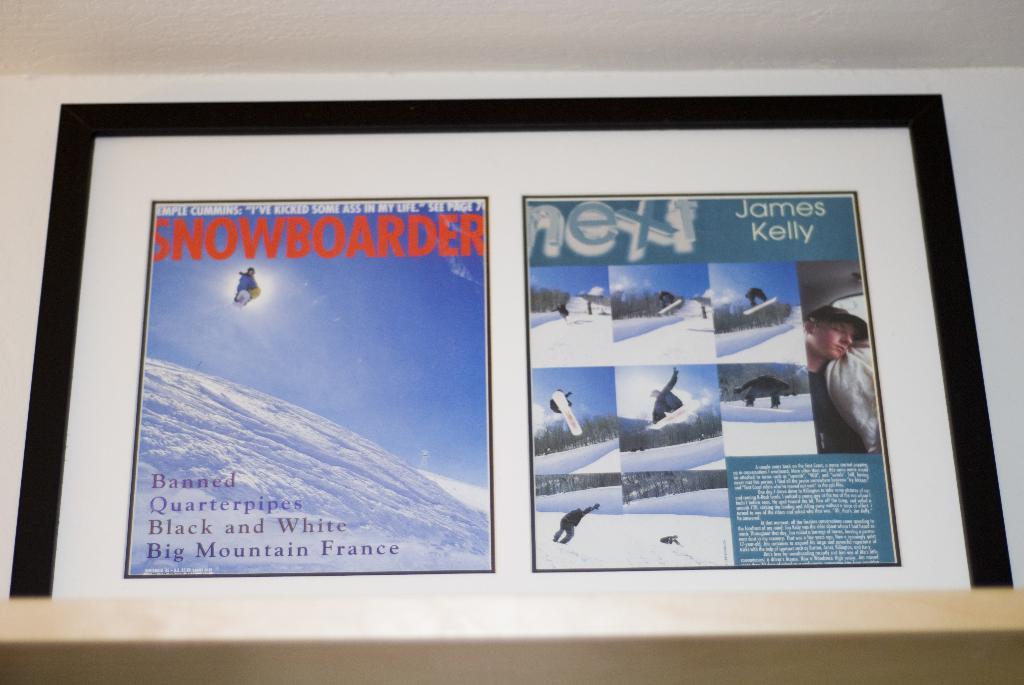Where is this mountain located?
Provide a short and direct response. France. What name is on the top right?
Provide a succinct answer. James kelly. 